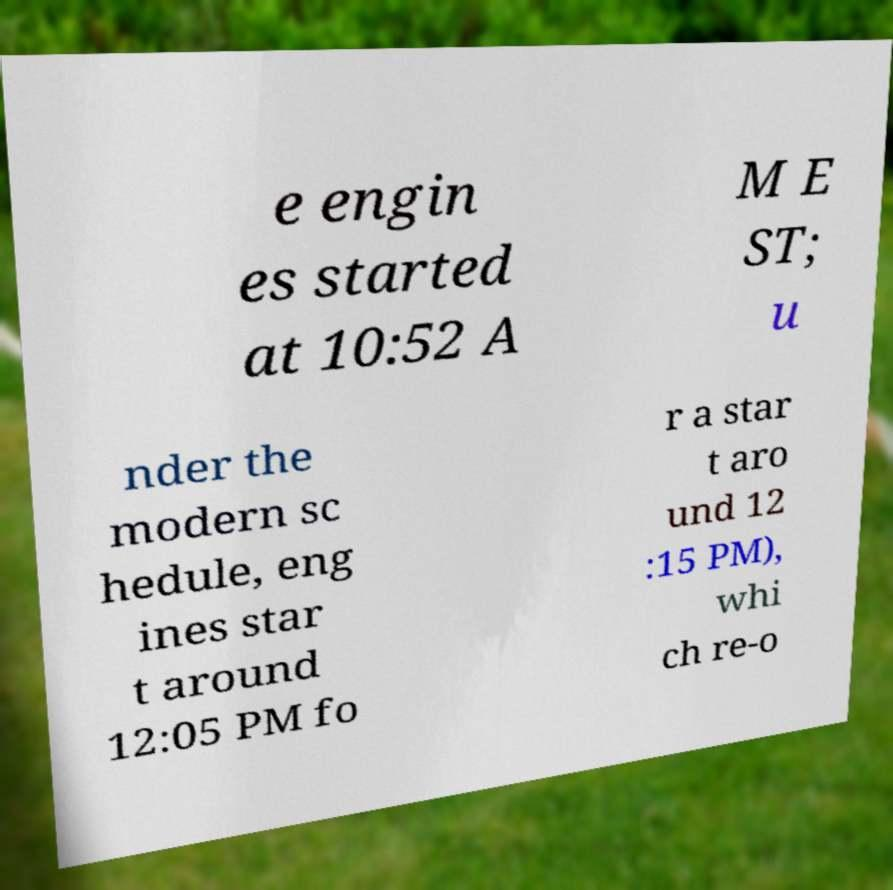I need the written content from this picture converted into text. Can you do that? e engin es started at 10:52 A M E ST; u nder the modern sc hedule, eng ines star t around 12:05 PM fo r a star t aro und 12 :15 PM), whi ch re-o 